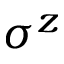<formula> <loc_0><loc_0><loc_500><loc_500>\sigma ^ { z }</formula> 